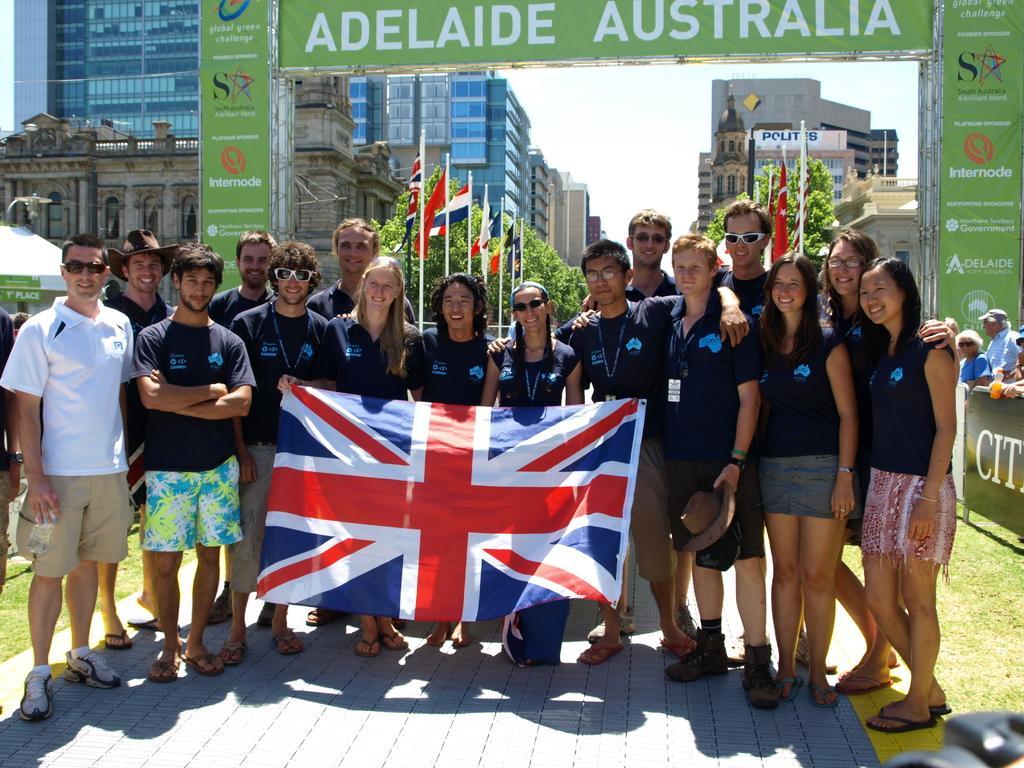Could you give a brief overview of what you see in this image? In this image we can see the people standing on the path and smiling. We can also see the flag. In the background we can see can arch with the text boards. We can also see the people, board, flags, trees and also the buildings. On the left we can see the tent for shelter. We can also see the sky and also the grass. 